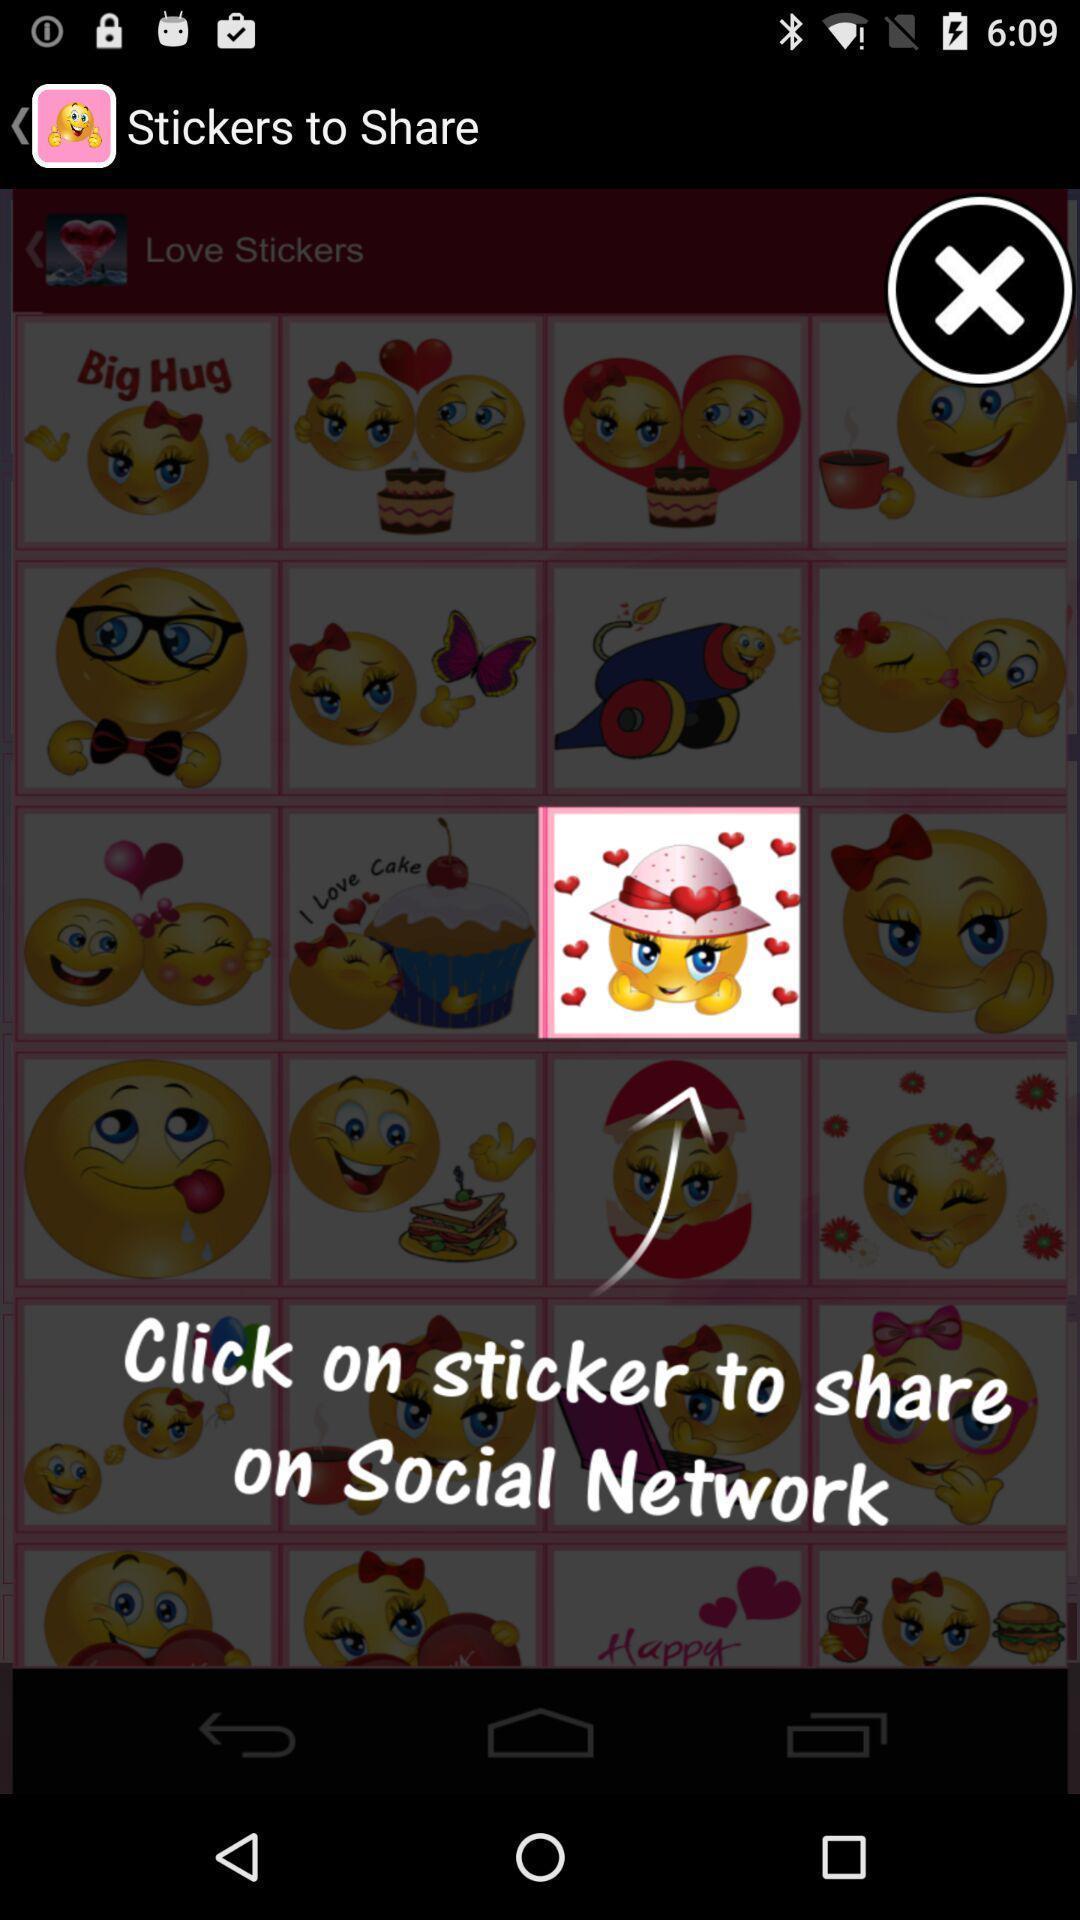Please provide a description for this image. Pop-up screen displaying with instructions to use the stickers. 